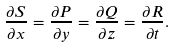Convert formula to latex. <formula><loc_0><loc_0><loc_500><loc_500>\frac { \partial S } { \partial x } = \frac { \partial P } { \partial y } = \frac { \partial Q } { \partial z } = \frac { \partial R } { \partial t } .</formula> 